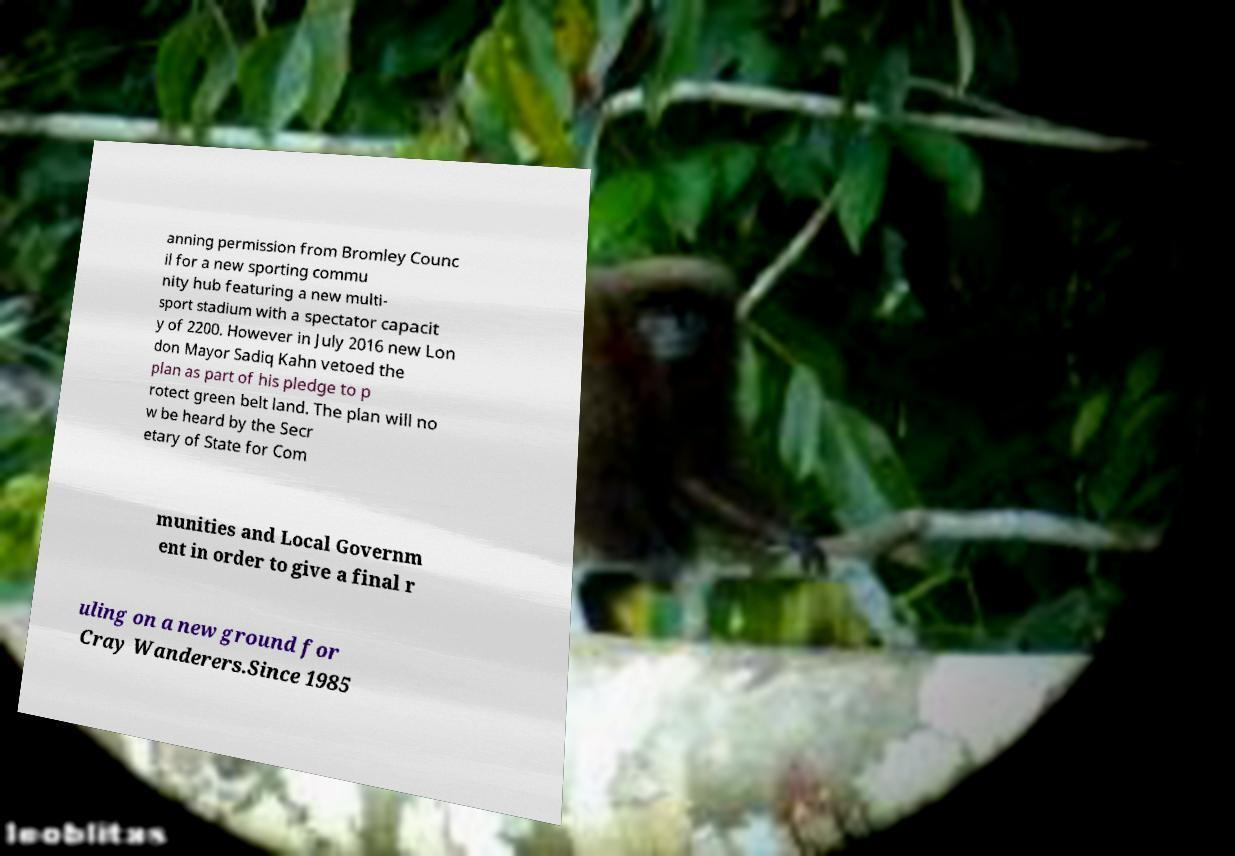There's text embedded in this image that I need extracted. Can you transcribe it verbatim? anning permission from Bromley Counc il for a new sporting commu nity hub featuring a new multi- sport stadium with a spectator capacit y of 2200. However in July 2016 new Lon don Mayor Sadiq Kahn vetoed the plan as part of his pledge to p rotect green belt land. The plan will no w be heard by the Secr etary of State for Com munities and Local Governm ent in order to give a final r uling on a new ground for Cray Wanderers.Since 1985 